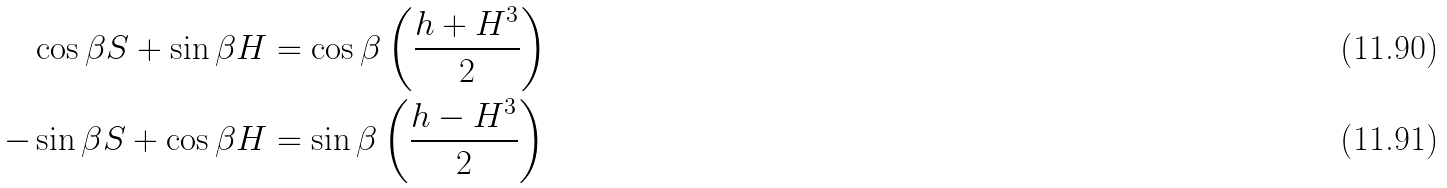Convert formula to latex. <formula><loc_0><loc_0><loc_500><loc_500>\cos \beta S + \sin \beta H & = \cos \beta \left ( \frac { h + H ^ { 3 } } { 2 } \right ) \\ - \sin \beta S + \cos \beta H & = \sin \beta \left ( \frac { h - H ^ { 3 } } { 2 } \right )</formula> 